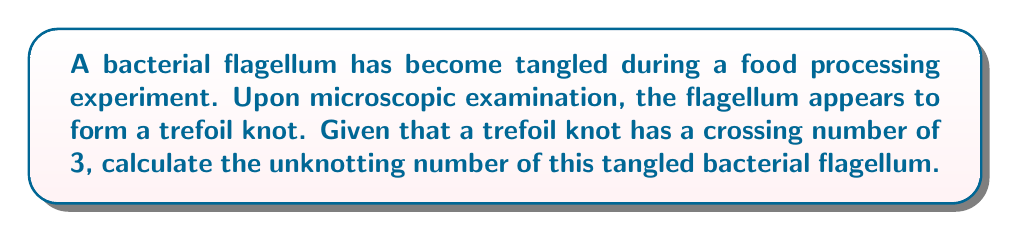Give your solution to this math problem. To solve this problem, we need to understand the relationship between the crossing number and the unknotting number for a trefoil knot:

1. The crossing number of a knot is the minimum number of crossings in any diagram of the knot. For a trefoil knot, this is 3.

2. The unknotting number of a knot is the minimum number of crossing changes required to transform the knot into an unknot (trivial knot).

3. For alternating knots, such as the trefoil knot, there is a theorem that states:

   $$u(K) \leq \frac{c(K)}{2}$$

   where $u(K)$ is the unknotting number and $c(K)$ is the crossing number.

4. For the trefoil knot:
   $$u(K) \leq \frac{3}{2} = 1.5$$

5. Since the unknotting number must be an integer, and we're looking for the minimum number of changes, we round down to 1.

6. It can be proven that a single crossing change is indeed sufficient to unknot a trefoil knot, and no fewer changes will suffice.

Therefore, the unknotting number of the tangled bacterial flagellum, assuming it forms a trefoil knot, is 1.
Answer: 1 